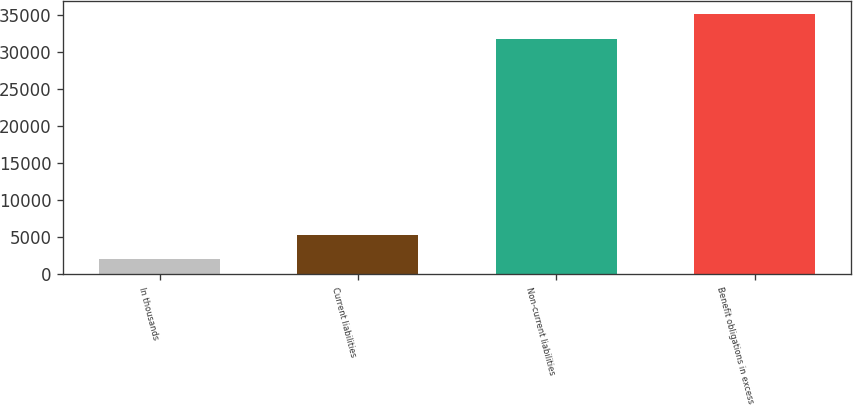<chart> <loc_0><loc_0><loc_500><loc_500><bar_chart><fcel>In thousands<fcel>Current liabilities<fcel>Non-current liabilities<fcel>Benefit obligations in excess<nl><fcel>2011<fcel>5318<fcel>31774<fcel>35081<nl></chart> 